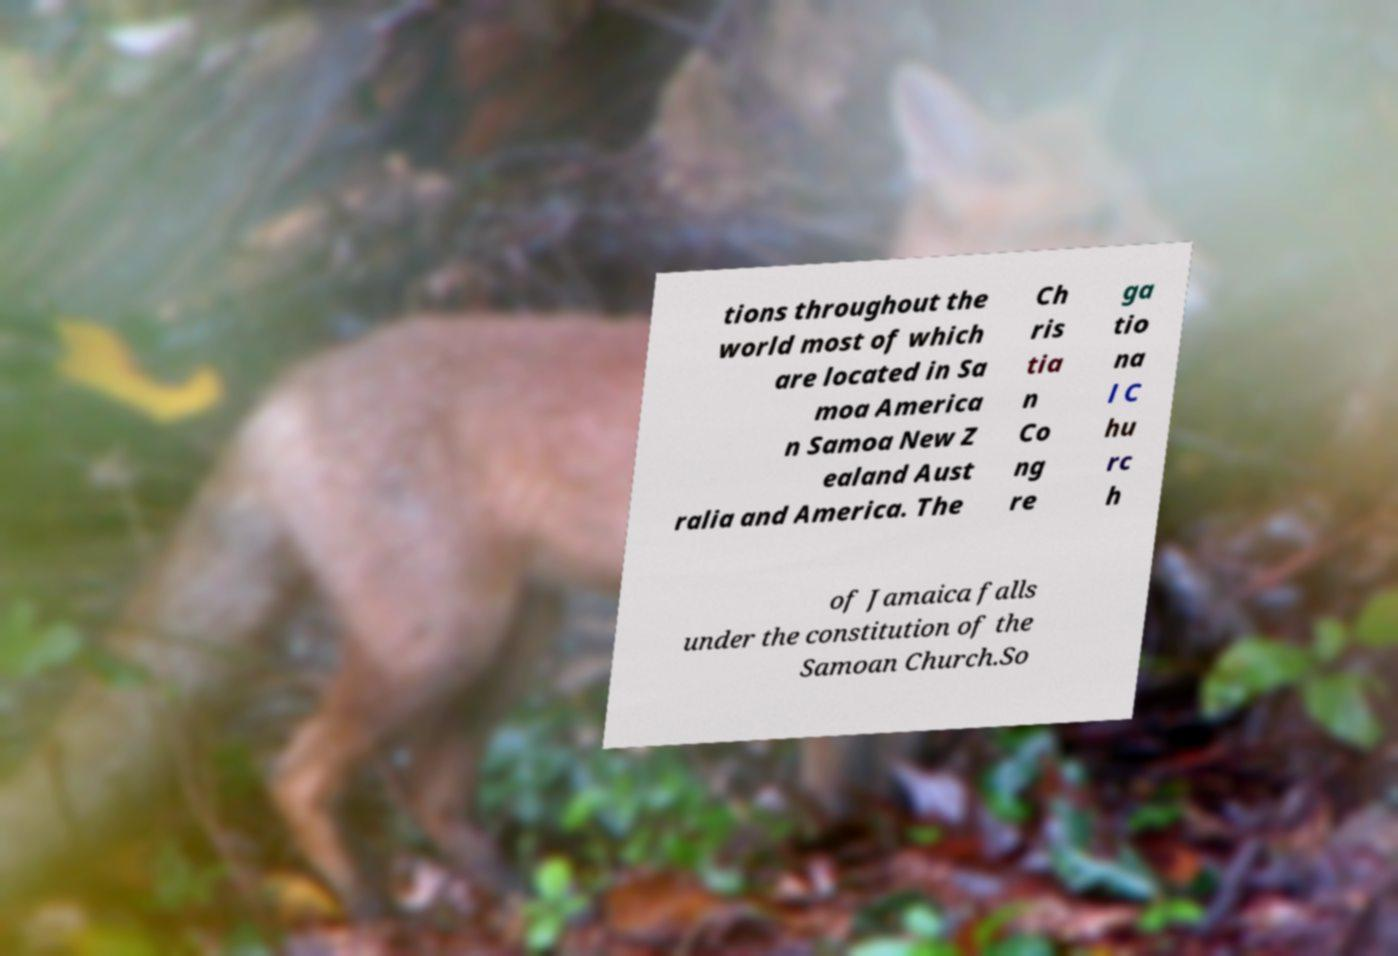There's text embedded in this image that I need extracted. Can you transcribe it verbatim? tions throughout the world most of which are located in Sa moa America n Samoa New Z ealand Aust ralia and America. The Ch ris tia n Co ng re ga tio na l C hu rc h of Jamaica falls under the constitution of the Samoan Church.So 